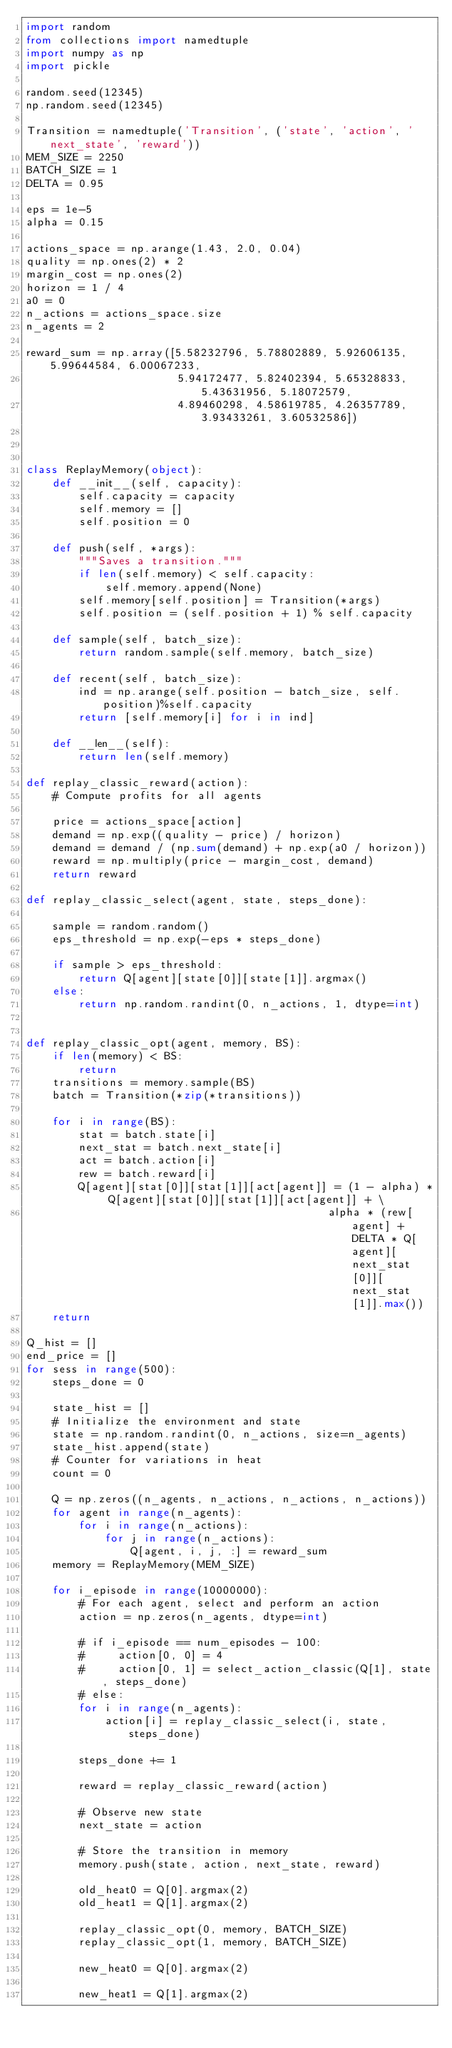<code> <loc_0><loc_0><loc_500><loc_500><_Python_>import random
from collections import namedtuple
import numpy as np
import pickle

random.seed(12345)
np.random.seed(12345)

Transition = namedtuple('Transition', ('state', 'action', 'next_state', 'reward'))
MEM_SIZE = 2250
BATCH_SIZE = 1
DELTA = 0.95

eps = 1e-5
alpha = 0.15

actions_space = np.arange(1.43, 2.0, 0.04)
quality = np.ones(2) * 2
margin_cost = np.ones(2)
horizon = 1 / 4
a0 = 0
n_actions = actions_space.size
n_agents = 2

reward_sum = np.array([5.58232796, 5.78802889, 5.92606135, 5.99644584, 6.00067233,
                       5.94172477, 5.82402394, 5.65328833, 5.43631956, 5.18072579,
                       4.89460298, 4.58619785, 4.26357789, 3.93433261, 3.60532586])



class ReplayMemory(object):
    def __init__(self, capacity):
        self.capacity = capacity
        self.memory = []
        self.position = 0

    def push(self, *args):
        """Saves a transition."""
        if len(self.memory) < self.capacity:
            self.memory.append(None)
        self.memory[self.position] = Transition(*args)
        self.position = (self.position + 1) % self.capacity

    def sample(self, batch_size):
        return random.sample(self.memory, batch_size)

    def recent(self, batch_size):
        ind = np.arange(self.position - batch_size, self.position)%self.capacity
        return [self.memory[i] for i in ind]

    def __len__(self):
        return len(self.memory)

def replay_classic_reward(action):
    # Compute profits for all agents

    price = actions_space[action]
    demand = np.exp((quality - price) / horizon)
    demand = demand / (np.sum(demand) + np.exp(a0 / horizon))
    reward = np.multiply(price - margin_cost, demand)
    return reward

def replay_classic_select(agent, state, steps_done):

    sample = random.random()
    eps_threshold = np.exp(-eps * steps_done)

    if sample > eps_threshold:
        return Q[agent][state[0]][state[1]].argmax()
    else:
        return np.random.randint(0, n_actions, 1, dtype=int)


def replay_classic_opt(agent, memory, BS):
    if len(memory) < BS:
        return
    transitions = memory.sample(BS)
    batch = Transition(*zip(*transitions))

    for i in range(BS):
        stat = batch.state[i]
        next_stat = batch.next_state[i]
        act = batch.action[i]
        rew = batch.reward[i]
        Q[agent][stat[0]][stat[1]][act[agent]] = (1 - alpha) * Q[agent][stat[0]][stat[1]][act[agent]] + \
                                              alpha * (rew[agent] + DELTA * Q[agent][next_stat[0]][next_stat[1]].max())
    return

Q_hist = []
end_price = []
for sess in range(500):
    steps_done = 0

    state_hist = []
    # Initialize the environment and state
    state = np.random.randint(0, n_actions, size=n_agents)
    state_hist.append(state)
    # Counter for variations in heat
    count = 0

    Q = np.zeros((n_agents, n_actions, n_actions, n_actions))
    for agent in range(n_agents):
        for i in range(n_actions):
            for j in range(n_actions):
                Q[agent, i, j, :] = reward_sum
    memory = ReplayMemory(MEM_SIZE)

    for i_episode in range(10000000):
        # For each agent, select and perform an action
        action = np.zeros(n_agents, dtype=int)

        # if i_episode == num_episodes - 100:
        #     action[0, 0] = 4
        #     action[0, 1] = select_action_classic(Q[1], state, steps_done)
        # else:
        for i in range(n_agents):
            action[i] = replay_classic_select(i, state, steps_done)

        steps_done += 1

        reward = replay_classic_reward(action)

        # Observe new state
        next_state = action

        # Store the transition in memory
        memory.push(state, action, next_state, reward)

        old_heat0 = Q[0].argmax(2)
        old_heat1 = Q[1].argmax(2)

        replay_classic_opt(0, memory, BATCH_SIZE)
        replay_classic_opt(1, memory, BATCH_SIZE)

        new_heat0 = Q[0].argmax(2)

        new_heat1 = Q[1].argmax(2)
</code> 